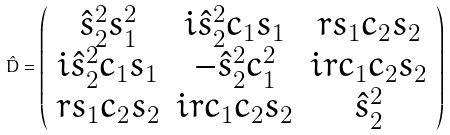Convert formula to latex. <formula><loc_0><loc_0><loc_500><loc_500>\hat { D } = \left ( \begin{array} { c c c } \hat { s } _ { 2 } ^ { 2 } s _ { 1 } ^ { 2 } & i \hat { s } _ { 2 } ^ { 2 } c _ { 1 } s _ { 1 } & r s _ { 1 } c _ { 2 } s _ { 2 } \\ i \hat { s } _ { 2 } ^ { 2 } c _ { 1 } s _ { 1 } & - \hat { s } _ { 2 } ^ { 2 } c _ { 1 } ^ { 2 } & i r c _ { 1 } c _ { 2 } s _ { 2 } \\ r s _ { 1 } c _ { 2 } s _ { 2 } & i r c _ { 1 } c _ { 2 } s _ { 2 } & \hat { s } _ { 2 } ^ { 2 } \\ \end{array} \right )</formula> 